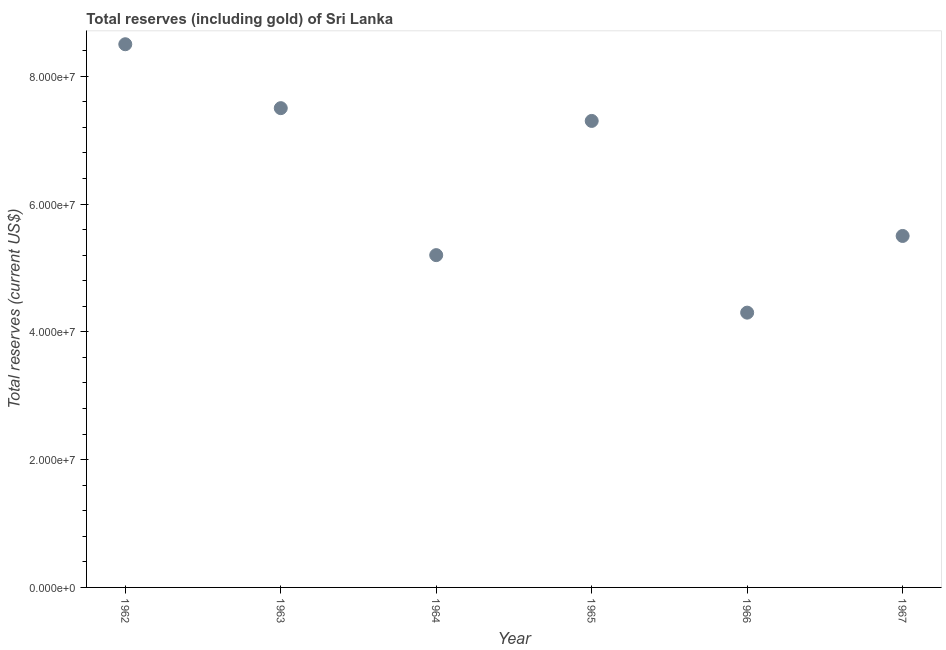What is the total reserves (including gold) in 1966?
Give a very brief answer. 4.30e+07. Across all years, what is the maximum total reserves (including gold)?
Offer a very short reply. 8.50e+07. Across all years, what is the minimum total reserves (including gold)?
Provide a short and direct response. 4.30e+07. In which year was the total reserves (including gold) maximum?
Provide a short and direct response. 1962. In which year was the total reserves (including gold) minimum?
Ensure brevity in your answer.  1966. What is the sum of the total reserves (including gold)?
Make the answer very short. 3.83e+08. What is the average total reserves (including gold) per year?
Ensure brevity in your answer.  6.38e+07. What is the median total reserves (including gold)?
Provide a succinct answer. 6.40e+07. What is the ratio of the total reserves (including gold) in 1963 to that in 1967?
Provide a short and direct response. 1.36. What is the difference between the highest and the second highest total reserves (including gold)?
Provide a succinct answer. 1.00e+07. What is the difference between the highest and the lowest total reserves (including gold)?
Provide a short and direct response. 4.20e+07. In how many years, is the total reserves (including gold) greater than the average total reserves (including gold) taken over all years?
Keep it short and to the point. 3. How many dotlines are there?
Provide a succinct answer. 1. How many years are there in the graph?
Provide a short and direct response. 6. Are the values on the major ticks of Y-axis written in scientific E-notation?
Your response must be concise. Yes. Does the graph contain grids?
Give a very brief answer. No. What is the title of the graph?
Keep it short and to the point. Total reserves (including gold) of Sri Lanka. What is the label or title of the Y-axis?
Make the answer very short. Total reserves (current US$). What is the Total reserves (current US$) in 1962?
Offer a terse response. 8.50e+07. What is the Total reserves (current US$) in 1963?
Your answer should be very brief. 7.50e+07. What is the Total reserves (current US$) in 1964?
Your answer should be compact. 5.20e+07. What is the Total reserves (current US$) in 1965?
Your response must be concise. 7.30e+07. What is the Total reserves (current US$) in 1966?
Give a very brief answer. 4.30e+07. What is the Total reserves (current US$) in 1967?
Provide a succinct answer. 5.50e+07. What is the difference between the Total reserves (current US$) in 1962 and 1964?
Provide a short and direct response. 3.30e+07. What is the difference between the Total reserves (current US$) in 1962 and 1965?
Provide a succinct answer. 1.20e+07. What is the difference between the Total reserves (current US$) in 1962 and 1966?
Ensure brevity in your answer.  4.20e+07. What is the difference between the Total reserves (current US$) in 1962 and 1967?
Your response must be concise. 3.00e+07. What is the difference between the Total reserves (current US$) in 1963 and 1964?
Provide a short and direct response. 2.30e+07. What is the difference between the Total reserves (current US$) in 1963 and 1965?
Offer a very short reply. 2.00e+06. What is the difference between the Total reserves (current US$) in 1963 and 1966?
Offer a terse response. 3.20e+07. What is the difference between the Total reserves (current US$) in 1964 and 1965?
Provide a succinct answer. -2.10e+07. What is the difference between the Total reserves (current US$) in 1964 and 1966?
Ensure brevity in your answer.  9.00e+06. What is the difference between the Total reserves (current US$) in 1964 and 1967?
Ensure brevity in your answer.  -3.00e+06. What is the difference between the Total reserves (current US$) in 1965 and 1966?
Provide a succinct answer. 3.00e+07. What is the difference between the Total reserves (current US$) in 1965 and 1967?
Offer a terse response. 1.80e+07. What is the difference between the Total reserves (current US$) in 1966 and 1967?
Provide a short and direct response. -1.20e+07. What is the ratio of the Total reserves (current US$) in 1962 to that in 1963?
Ensure brevity in your answer.  1.13. What is the ratio of the Total reserves (current US$) in 1962 to that in 1964?
Keep it short and to the point. 1.64. What is the ratio of the Total reserves (current US$) in 1962 to that in 1965?
Provide a short and direct response. 1.16. What is the ratio of the Total reserves (current US$) in 1962 to that in 1966?
Keep it short and to the point. 1.98. What is the ratio of the Total reserves (current US$) in 1962 to that in 1967?
Your response must be concise. 1.54. What is the ratio of the Total reserves (current US$) in 1963 to that in 1964?
Make the answer very short. 1.44. What is the ratio of the Total reserves (current US$) in 1963 to that in 1965?
Keep it short and to the point. 1.03. What is the ratio of the Total reserves (current US$) in 1963 to that in 1966?
Keep it short and to the point. 1.74. What is the ratio of the Total reserves (current US$) in 1963 to that in 1967?
Offer a very short reply. 1.36. What is the ratio of the Total reserves (current US$) in 1964 to that in 1965?
Your response must be concise. 0.71. What is the ratio of the Total reserves (current US$) in 1964 to that in 1966?
Your answer should be compact. 1.21. What is the ratio of the Total reserves (current US$) in 1964 to that in 1967?
Provide a succinct answer. 0.94. What is the ratio of the Total reserves (current US$) in 1965 to that in 1966?
Provide a succinct answer. 1.7. What is the ratio of the Total reserves (current US$) in 1965 to that in 1967?
Make the answer very short. 1.33. What is the ratio of the Total reserves (current US$) in 1966 to that in 1967?
Offer a terse response. 0.78. 